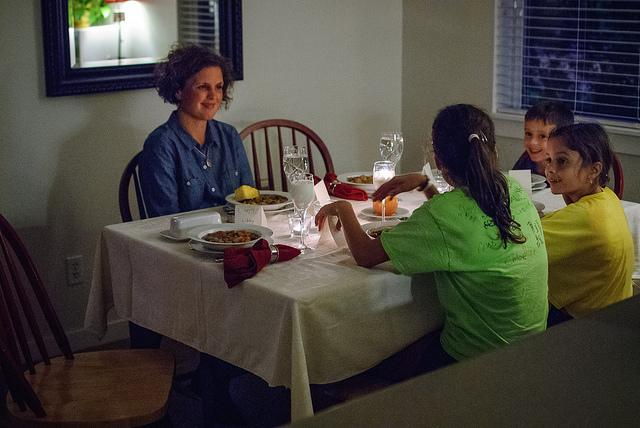What is holding the red napkin together? napkin ring 